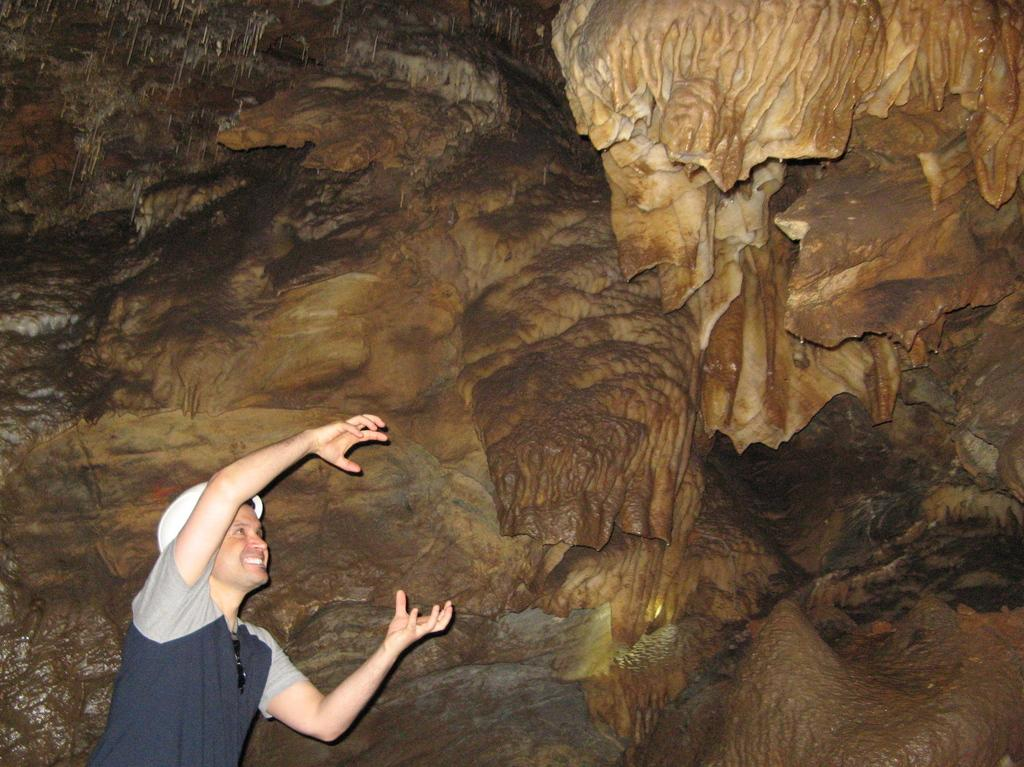What type of location is depicted in the image? The image shows the inside view of a cave. Can you describe the person in the image? There is a man in the image. What is the man's facial expression? The man is smiling. What type of clothing is the man wearing? The man is wearing a t-shirt. What type of ornament is hanging from the ceiling of the cave in the image? There is no ornament hanging from the ceiling of the cave in the image. What riddle is the man trying to solve in the image? There is no riddle present in the image; the man is simply smiling. 